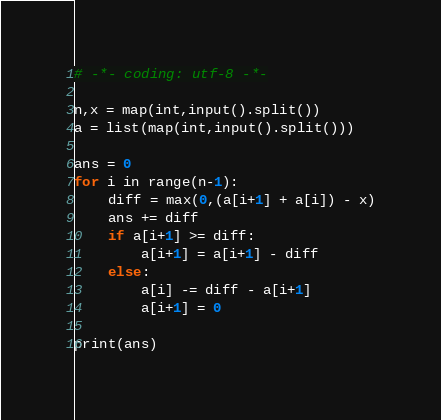Convert code to text. <code><loc_0><loc_0><loc_500><loc_500><_Python_># -*- coding: utf-8 -*-

n,x = map(int,input().split())
a = list(map(int,input().split()))

ans = 0
for i in range(n-1):
    diff = max(0,(a[i+1] + a[i]) - x)
    ans += diff
    if a[i+1] >= diff:
        a[i+1] = a[i+1] - diff
    else:
        a[i] -= diff - a[i+1]
        a[i+1] = 0

print(ans)</code> 